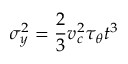<formula> <loc_0><loc_0><loc_500><loc_500>\sigma _ { y } ^ { 2 } = \frac { 2 } { 3 } v _ { c } ^ { 2 } \tau _ { \theta } t ^ { 3 }</formula> 